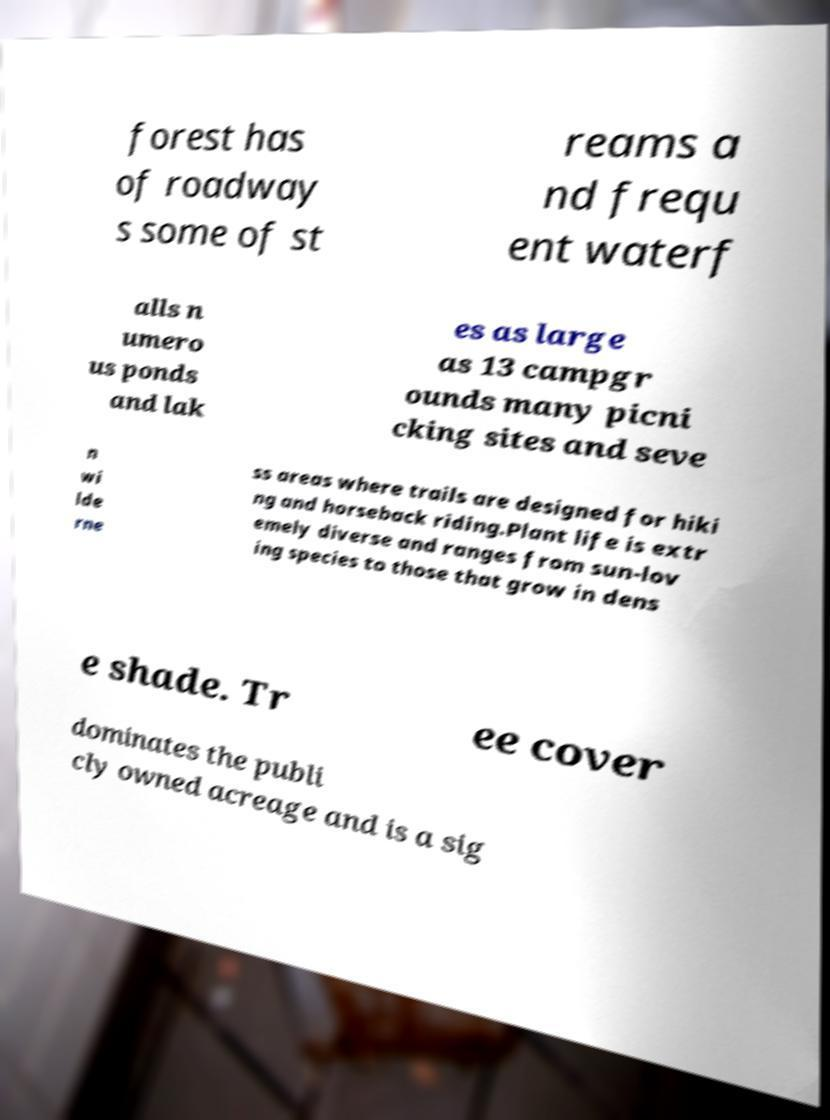Could you extract and type out the text from this image? forest has of roadway s some of st reams a nd frequ ent waterf alls n umero us ponds and lak es as large as 13 campgr ounds many picni cking sites and seve n wi lde rne ss areas where trails are designed for hiki ng and horseback riding.Plant life is extr emely diverse and ranges from sun-lov ing species to those that grow in dens e shade. Tr ee cover dominates the publi cly owned acreage and is a sig 